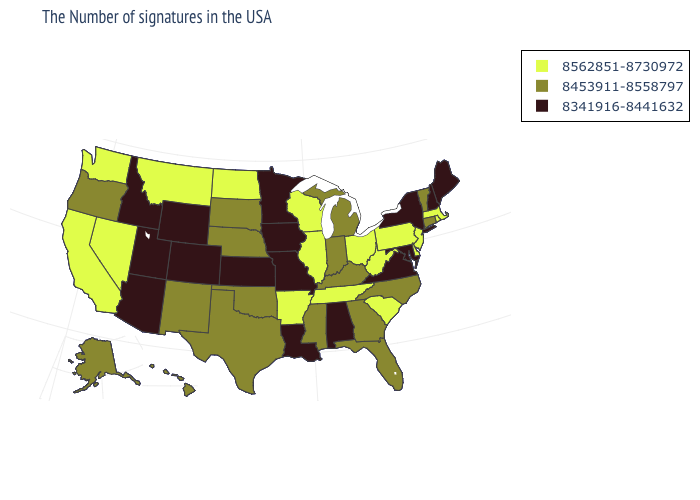Among the states that border Mississippi , which have the highest value?
Be succinct. Tennessee, Arkansas. What is the value of Wyoming?
Write a very short answer. 8341916-8441632. Name the states that have a value in the range 8341916-8441632?
Concise answer only. Maine, New Hampshire, New York, Maryland, Virginia, Alabama, Louisiana, Missouri, Minnesota, Iowa, Kansas, Wyoming, Colorado, Utah, Arizona, Idaho. Among the states that border Pennsylvania , does New York have the highest value?
Write a very short answer. No. Does the map have missing data?
Be succinct. No. What is the value of California?
Keep it brief. 8562851-8730972. Does the map have missing data?
Short answer required. No. Does Vermont have a higher value than Georgia?
Be succinct. No. Name the states that have a value in the range 8453911-8558797?
Answer briefly. Vermont, Connecticut, North Carolina, Florida, Georgia, Michigan, Kentucky, Indiana, Mississippi, Nebraska, Oklahoma, Texas, South Dakota, New Mexico, Oregon, Alaska, Hawaii. What is the lowest value in states that border Kansas?
Answer briefly. 8341916-8441632. Does the map have missing data?
Concise answer only. No. Which states have the lowest value in the MidWest?
Keep it brief. Missouri, Minnesota, Iowa, Kansas. What is the value of California?
Answer briefly. 8562851-8730972. What is the highest value in the Northeast ?
Write a very short answer. 8562851-8730972. Among the states that border New Jersey , does New York have the lowest value?
Give a very brief answer. Yes. 